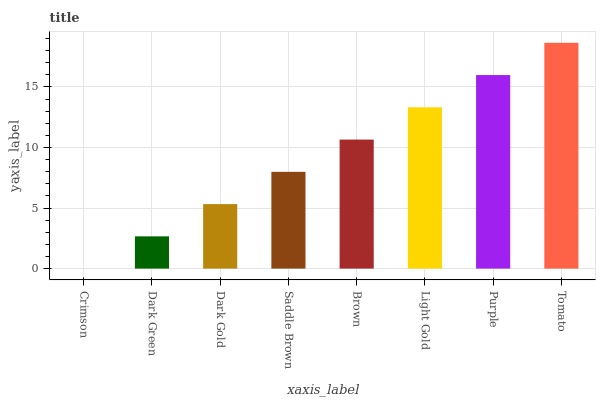Is Crimson the minimum?
Answer yes or no. Yes. Is Tomato the maximum?
Answer yes or no. Yes. Is Dark Green the minimum?
Answer yes or no. No. Is Dark Green the maximum?
Answer yes or no. No. Is Dark Green greater than Crimson?
Answer yes or no. Yes. Is Crimson less than Dark Green?
Answer yes or no. Yes. Is Crimson greater than Dark Green?
Answer yes or no. No. Is Dark Green less than Crimson?
Answer yes or no. No. Is Brown the high median?
Answer yes or no. Yes. Is Saddle Brown the low median?
Answer yes or no. Yes. Is Tomato the high median?
Answer yes or no. No. Is Crimson the low median?
Answer yes or no. No. 